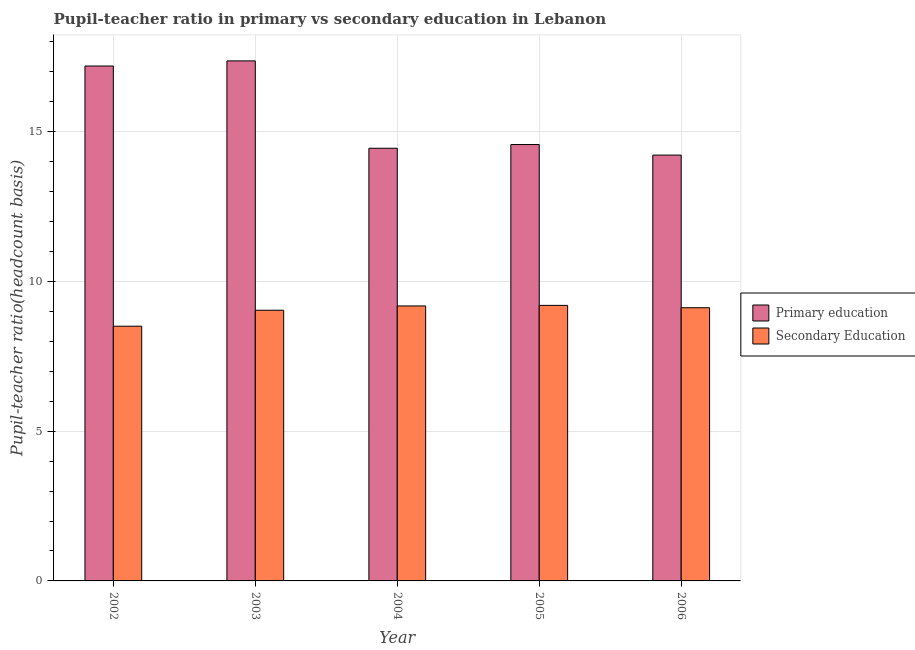How many different coloured bars are there?
Offer a very short reply. 2. How many groups of bars are there?
Keep it short and to the point. 5. Are the number of bars per tick equal to the number of legend labels?
Your response must be concise. Yes. Are the number of bars on each tick of the X-axis equal?
Your response must be concise. Yes. How many bars are there on the 3rd tick from the left?
Make the answer very short. 2. How many bars are there on the 4th tick from the right?
Provide a succinct answer. 2. What is the label of the 1st group of bars from the left?
Offer a very short reply. 2002. What is the pupil-teacher ratio in primary education in 2002?
Make the answer very short. 17.2. Across all years, what is the maximum pupil teacher ratio on secondary education?
Provide a succinct answer. 9.2. Across all years, what is the minimum pupil-teacher ratio in primary education?
Your response must be concise. 14.22. What is the total pupil teacher ratio on secondary education in the graph?
Your answer should be compact. 45.06. What is the difference between the pupil-teacher ratio in primary education in 2005 and that in 2006?
Ensure brevity in your answer.  0.35. What is the difference between the pupil teacher ratio on secondary education in 2006 and the pupil-teacher ratio in primary education in 2002?
Offer a very short reply. 0.62. What is the average pupil-teacher ratio in primary education per year?
Offer a terse response. 15.56. What is the ratio of the pupil-teacher ratio in primary education in 2003 to that in 2005?
Offer a terse response. 1.19. Is the difference between the pupil teacher ratio on secondary education in 2003 and 2004 greater than the difference between the pupil-teacher ratio in primary education in 2003 and 2004?
Offer a terse response. No. What is the difference between the highest and the second highest pupil-teacher ratio in primary education?
Your response must be concise. 0.17. What is the difference between the highest and the lowest pupil teacher ratio on secondary education?
Ensure brevity in your answer.  0.7. In how many years, is the pupil-teacher ratio in primary education greater than the average pupil-teacher ratio in primary education taken over all years?
Your answer should be very brief. 2. Is the sum of the pupil teacher ratio on secondary education in 2002 and 2005 greater than the maximum pupil-teacher ratio in primary education across all years?
Your answer should be very brief. Yes. What does the 1st bar from the left in 2006 represents?
Your response must be concise. Primary education. What is the difference between two consecutive major ticks on the Y-axis?
Keep it short and to the point. 5. Are the values on the major ticks of Y-axis written in scientific E-notation?
Your answer should be compact. No. Does the graph contain any zero values?
Provide a short and direct response. No. Where does the legend appear in the graph?
Ensure brevity in your answer.  Center right. How many legend labels are there?
Make the answer very short. 2. How are the legend labels stacked?
Provide a succinct answer. Vertical. What is the title of the graph?
Your answer should be compact. Pupil-teacher ratio in primary vs secondary education in Lebanon. Does "Urban agglomerations" appear as one of the legend labels in the graph?
Give a very brief answer. No. What is the label or title of the Y-axis?
Keep it short and to the point. Pupil-teacher ratio(headcount basis). What is the Pupil-teacher ratio(headcount basis) in Primary education in 2002?
Make the answer very short. 17.2. What is the Pupil-teacher ratio(headcount basis) in Secondary Education in 2002?
Your response must be concise. 8.51. What is the Pupil-teacher ratio(headcount basis) of Primary education in 2003?
Give a very brief answer. 17.37. What is the Pupil-teacher ratio(headcount basis) in Secondary Education in 2003?
Ensure brevity in your answer.  9.04. What is the Pupil-teacher ratio(headcount basis) of Primary education in 2004?
Make the answer very short. 14.45. What is the Pupil-teacher ratio(headcount basis) of Secondary Education in 2004?
Offer a very short reply. 9.18. What is the Pupil-teacher ratio(headcount basis) in Primary education in 2005?
Your response must be concise. 14.57. What is the Pupil-teacher ratio(headcount basis) in Secondary Education in 2005?
Keep it short and to the point. 9.2. What is the Pupil-teacher ratio(headcount basis) of Primary education in 2006?
Your answer should be compact. 14.22. What is the Pupil-teacher ratio(headcount basis) in Secondary Education in 2006?
Ensure brevity in your answer.  9.12. Across all years, what is the maximum Pupil-teacher ratio(headcount basis) of Primary education?
Keep it short and to the point. 17.37. Across all years, what is the maximum Pupil-teacher ratio(headcount basis) of Secondary Education?
Your answer should be very brief. 9.2. Across all years, what is the minimum Pupil-teacher ratio(headcount basis) of Primary education?
Your response must be concise. 14.22. Across all years, what is the minimum Pupil-teacher ratio(headcount basis) of Secondary Education?
Offer a very short reply. 8.51. What is the total Pupil-teacher ratio(headcount basis) in Primary education in the graph?
Give a very brief answer. 77.81. What is the total Pupil-teacher ratio(headcount basis) in Secondary Education in the graph?
Your answer should be compact. 45.06. What is the difference between the Pupil-teacher ratio(headcount basis) in Primary education in 2002 and that in 2003?
Ensure brevity in your answer.  -0.17. What is the difference between the Pupil-teacher ratio(headcount basis) in Secondary Education in 2002 and that in 2003?
Keep it short and to the point. -0.53. What is the difference between the Pupil-teacher ratio(headcount basis) in Primary education in 2002 and that in 2004?
Offer a terse response. 2.75. What is the difference between the Pupil-teacher ratio(headcount basis) in Secondary Education in 2002 and that in 2004?
Provide a succinct answer. -0.68. What is the difference between the Pupil-teacher ratio(headcount basis) in Primary education in 2002 and that in 2005?
Your answer should be very brief. 2.62. What is the difference between the Pupil-teacher ratio(headcount basis) in Secondary Education in 2002 and that in 2005?
Make the answer very short. -0.7. What is the difference between the Pupil-teacher ratio(headcount basis) in Primary education in 2002 and that in 2006?
Provide a succinct answer. 2.98. What is the difference between the Pupil-teacher ratio(headcount basis) of Secondary Education in 2002 and that in 2006?
Provide a succinct answer. -0.62. What is the difference between the Pupil-teacher ratio(headcount basis) in Primary education in 2003 and that in 2004?
Keep it short and to the point. 2.92. What is the difference between the Pupil-teacher ratio(headcount basis) of Secondary Education in 2003 and that in 2004?
Offer a very short reply. -0.14. What is the difference between the Pupil-teacher ratio(headcount basis) of Primary education in 2003 and that in 2005?
Your answer should be very brief. 2.79. What is the difference between the Pupil-teacher ratio(headcount basis) of Secondary Education in 2003 and that in 2005?
Ensure brevity in your answer.  -0.16. What is the difference between the Pupil-teacher ratio(headcount basis) of Primary education in 2003 and that in 2006?
Give a very brief answer. 3.15. What is the difference between the Pupil-teacher ratio(headcount basis) of Secondary Education in 2003 and that in 2006?
Give a very brief answer. -0.08. What is the difference between the Pupil-teacher ratio(headcount basis) in Primary education in 2004 and that in 2005?
Your response must be concise. -0.12. What is the difference between the Pupil-teacher ratio(headcount basis) in Secondary Education in 2004 and that in 2005?
Ensure brevity in your answer.  -0.02. What is the difference between the Pupil-teacher ratio(headcount basis) in Primary education in 2004 and that in 2006?
Ensure brevity in your answer.  0.23. What is the difference between the Pupil-teacher ratio(headcount basis) in Secondary Education in 2004 and that in 2006?
Give a very brief answer. 0.06. What is the difference between the Pupil-teacher ratio(headcount basis) of Primary education in 2005 and that in 2006?
Give a very brief answer. 0.35. What is the difference between the Pupil-teacher ratio(headcount basis) of Secondary Education in 2005 and that in 2006?
Ensure brevity in your answer.  0.08. What is the difference between the Pupil-teacher ratio(headcount basis) of Primary education in 2002 and the Pupil-teacher ratio(headcount basis) of Secondary Education in 2003?
Offer a terse response. 8.16. What is the difference between the Pupil-teacher ratio(headcount basis) in Primary education in 2002 and the Pupil-teacher ratio(headcount basis) in Secondary Education in 2004?
Keep it short and to the point. 8.01. What is the difference between the Pupil-teacher ratio(headcount basis) in Primary education in 2002 and the Pupil-teacher ratio(headcount basis) in Secondary Education in 2005?
Your answer should be compact. 7.99. What is the difference between the Pupil-teacher ratio(headcount basis) of Primary education in 2002 and the Pupil-teacher ratio(headcount basis) of Secondary Education in 2006?
Make the answer very short. 8.07. What is the difference between the Pupil-teacher ratio(headcount basis) in Primary education in 2003 and the Pupil-teacher ratio(headcount basis) in Secondary Education in 2004?
Ensure brevity in your answer.  8.18. What is the difference between the Pupil-teacher ratio(headcount basis) of Primary education in 2003 and the Pupil-teacher ratio(headcount basis) of Secondary Education in 2005?
Your answer should be very brief. 8.17. What is the difference between the Pupil-teacher ratio(headcount basis) in Primary education in 2003 and the Pupil-teacher ratio(headcount basis) in Secondary Education in 2006?
Your answer should be compact. 8.24. What is the difference between the Pupil-teacher ratio(headcount basis) of Primary education in 2004 and the Pupil-teacher ratio(headcount basis) of Secondary Education in 2005?
Your answer should be very brief. 5.25. What is the difference between the Pupil-teacher ratio(headcount basis) of Primary education in 2004 and the Pupil-teacher ratio(headcount basis) of Secondary Education in 2006?
Your response must be concise. 5.33. What is the difference between the Pupil-teacher ratio(headcount basis) in Primary education in 2005 and the Pupil-teacher ratio(headcount basis) in Secondary Education in 2006?
Ensure brevity in your answer.  5.45. What is the average Pupil-teacher ratio(headcount basis) of Primary education per year?
Offer a very short reply. 15.56. What is the average Pupil-teacher ratio(headcount basis) of Secondary Education per year?
Keep it short and to the point. 9.01. In the year 2002, what is the difference between the Pupil-teacher ratio(headcount basis) of Primary education and Pupil-teacher ratio(headcount basis) of Secondary Education?
Provide a succinct answer. 8.69. In the year 2003, what is the difference between the Pupil-teacher ratio(headcount basis) of Primary education and Pupil-teacher ratio(headcount basis) of Secondary Education?
Keep it short and to the point. 8.33. In the year 2004, what is the difference between the Pupil-teacher ratio(headcount basis) in Primary education and Pupil-teacher ratio(headcount basis) in Secondary Education?
Offer a terse response. 5.27. In the year 2005, what is the difference between the Pupil-teacher ratio(headcount basis) of Primary education and Pupil-teacher ratio(headcount basis) of Secondary Education?
Your answer should be compact. 5.37. In the year 2006, what is the difference between the Pupil-teacher ratio(headcount basis) in Primary education and Pupil-teacher ratio(headcount basis) in Secondary Education?
Keep it short and to the point. 5.1. What is the ratio of the Pupil-teacher ratio(headcount basis) of Primary education in 2002 to that in 2003?
Offer a very short reply. 0.99. What is the ratio of the Pupil-teacher ratio(headcount basis) in Secondary Education in 2002 to that in 2003?
Your response must be concise. 0.94. What is the ratio of the Pupil-teacher ratio(headcount basis) of Primary education in 2002 to that in 2004?
Provide a short and direct response. 1.19. What is the ratio of the Pupil-teacher ratio(headcount basis) in Secondary Education in 2002 to that in 2004?
Make the answer very short. 0.93. What is the ratio of the Pupil-teacher ratio(headcount basis) in Primary education in 2002 to that in 2005?
Your answer should be compact. 1.18. What is the ratio of the Pupil-teacher ratio(headcount basis) in Secondary Education in 2002 to that in 2005?
Provide a succinct answer. 0.92. What is the ratio of the Pupil-teacher ratio(headcount basis) of Primary education in 2002 to that in 2006?
Your answer should be very brief. 1.21. What is the ratio of the Pupil-teacher ratio(headcount basis) in Secondary Education in 2002 to that in 2006?
Offer a terse response. 0.93. What is the ratio of the Pupil-teacher ratio(headcount basis) in Primary education in 2003 to that in 2004?
Your response must be concise. 1.2. What is the ratio of the Pupil-teacher ratio(headcount basis) of Secondary Education in 2003 to that in 2004?
Keep it short and to the point. 0.98. What is the ratio of the Pupil-teacher ratio(headcount basis) of Primary education in 2003 to that in 2005?
Ensure brevity in your answer.  1.19. What is the ratio of the Pupil-teacher ratio(headcount basis) of Secondary Education in 2003 to that in 2005?
Provide a succinct answer. 0.98. What is the ratio of the Pupil-teacher ratio(headcount basis) in Primary education in 2003 to that in 2006?
Your answer should be compact. 1.22. What is the ratio of the Pupil-teacher ratio(headcount basis) of Primary education in 2004 to that in 2006?
Offer a very short reply. 1.02. What is the ratio of the Pupil-teacher ratio(headcount basis) in Secondary Education in 2004 to that in 2006?
Give a very brief answer. 1.01. What is the ratio of the Pupil-teacher ratio(headcount basis) of Primary education in 2005 to that in 2006?
Give a very brief answer. 1.02. What is the ratio of the Pupil-teacher ratio(headcount basis) of Secondary Education in 2005 to that in 2006?
Your response must be concise. 1.01. What is the difference between the highest and the second highest Pupil-teacher ratio(headcount basis) of Primary education?
Your response must be concise. 0.17. What is the difference between the highest and the second highest Pupil-teacher ratio(headcount basis) of Secondary Education?
Keep it short and to the point. 0.02. What is the difference between the highest and the lowest Pupil-teacher ratio(headcount basis) of Primary education?
Offer a very short reply. 3.15. What is the difference between the highest and the lowest Pupil-teacher ratio(headcount basis) in Secondary Education?
Offer a terse response. 0.7. 